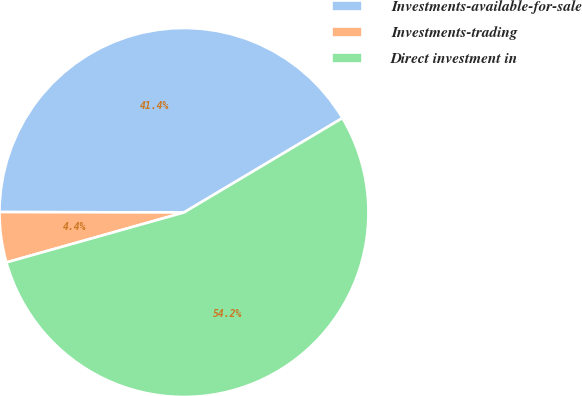Convert chart. <chart><loc_0><loc_0><loc_500><loc_500><pie_chart><fcel>Investments-available-for-sale<fcel>Investments-trading<fcel>Direct investment in<nl><fcel>41.41%<fcel>4.4%<fcel>54.18%<nl></chart> 